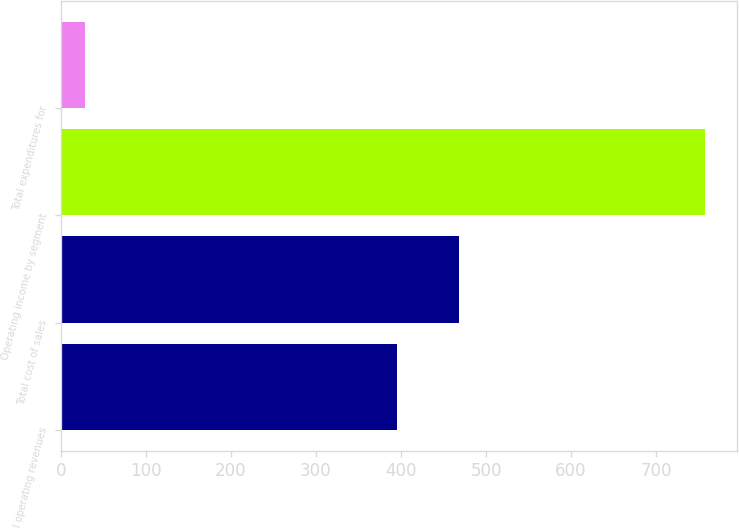Convert chart. <chart><loc_0><loc_0><loc_500><loc_500><bar_chart><fcel>Total operating revenues<fcel>Total cost of sales<fcel>Operating income by segment<fcel>Total expenditures for<nl><fcel>395<fcel>467.8<fcel>757<fcel>29<nl></chart> 